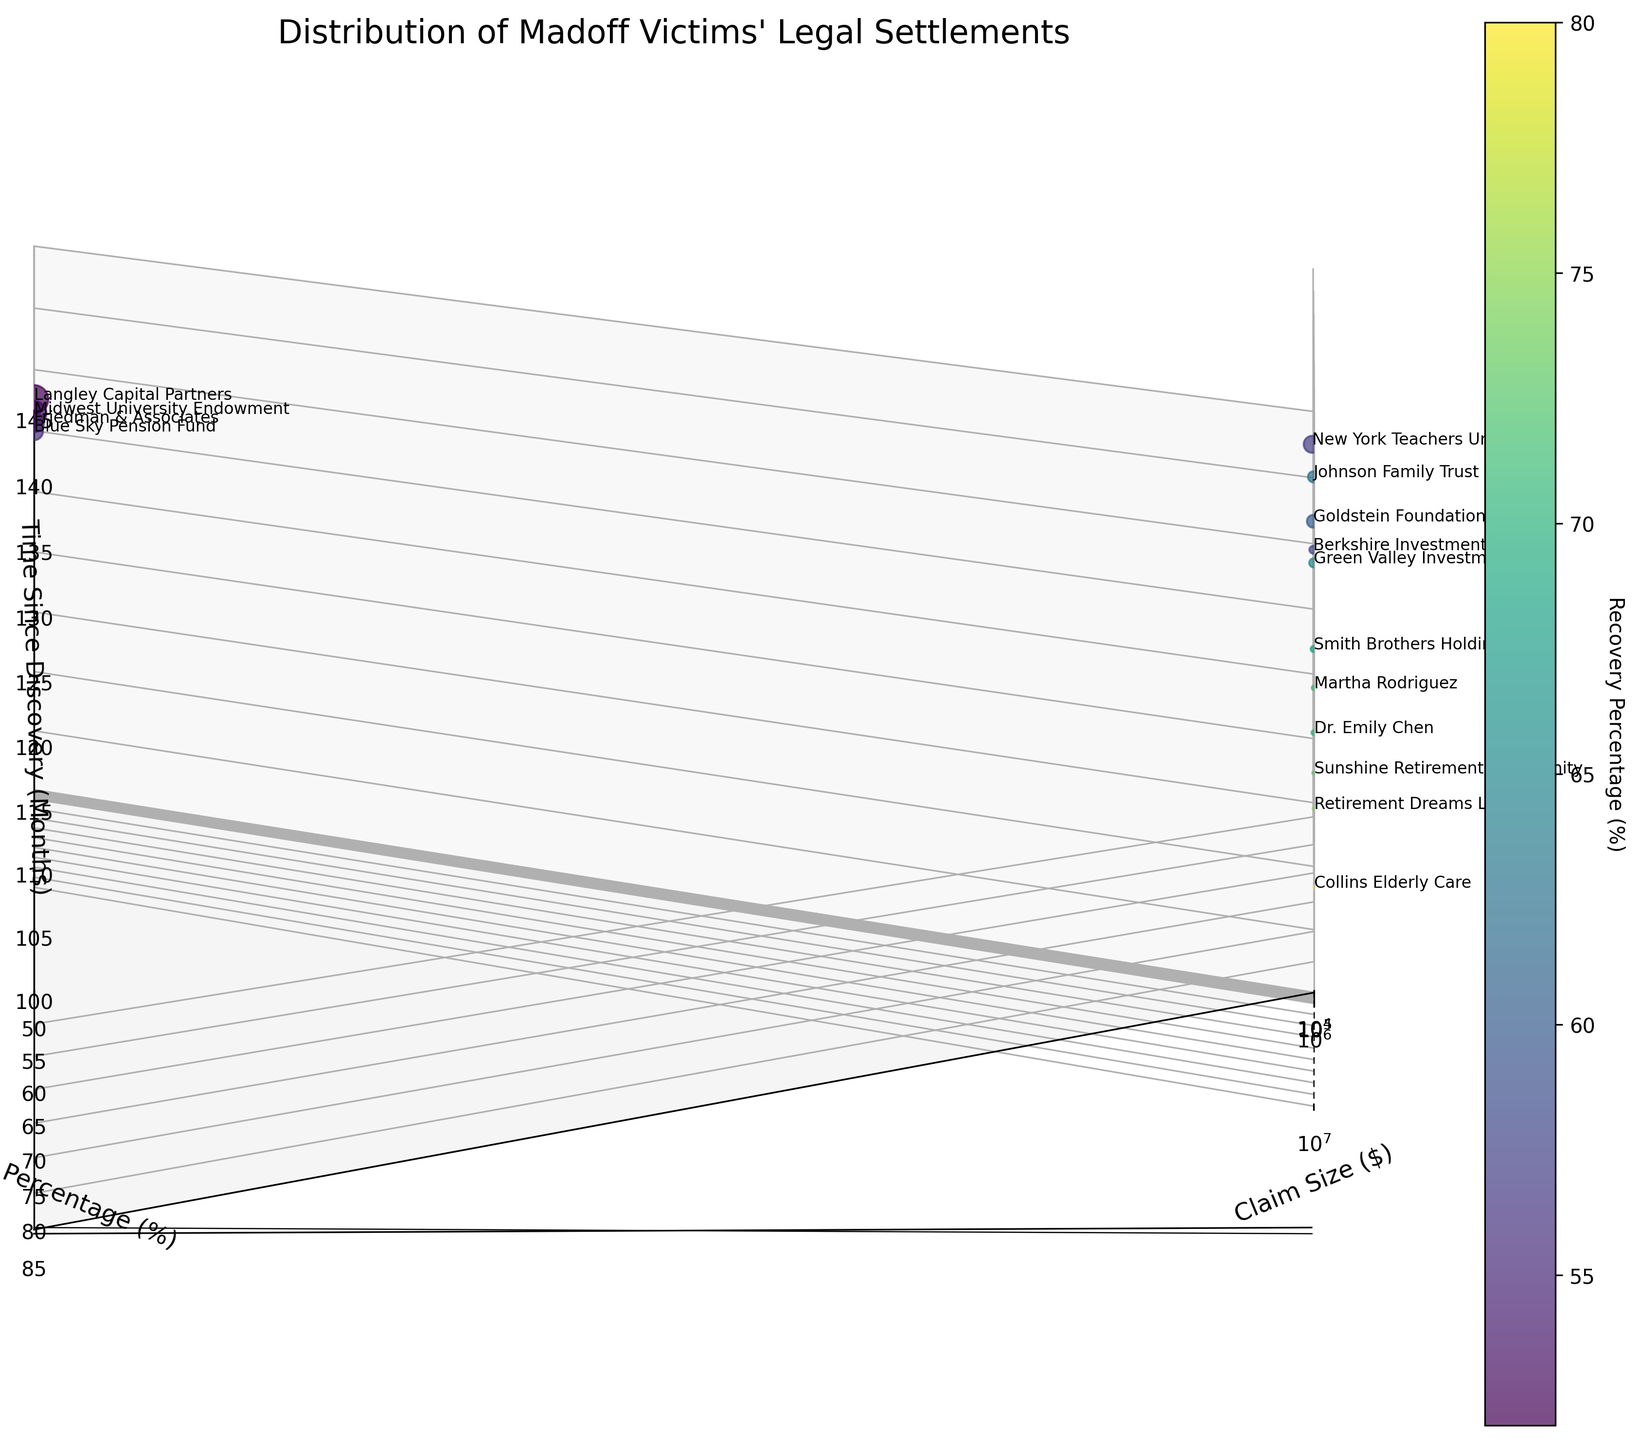What is the title of the figure? The title is clearly shown at the top of the figure. It helps us understand the purpose of the plot.
Answer: Distribution of Madoff Victims' Legal Settlements What is the range of the 'Claim Size' axis? The range can be noted by looking at the x-axis labels from left to right.
Answer: $10,000 to $20,000,000 Which axis represents the 'Time Since Discovery (Months)'? The axis labels are clearly specified. The 'Time Since Discovery (Months)' label is on the z-axis.
Answer: z-axis How many data points are plotted in the figure? We count the number of individual points scattered in the plot. Each point represents a victim.
Answer: 15 Which data point has the highest 'Recovery Percentage'? We look for the point with the highest value on the y-axis (Recovery Percentage)
Answer: Collins Elderly Care What is the relationship between 'Claim Size' and 'Recovery Percentage' for Friedman & Associates? Locate Friedman & Associates on the plot based on labels and check its positions on the 'Claim Size' and 'Recovery Percentage' axes.
Answer: Claim Size: $5,000,000, Recovery Percentage: 55% 1. Identify relevant points.
2. Sum their 'Time Since Discovery (Months)' (132+136+128+134+140+135+126).
3. Compute the average by dividing by the number of points (7). (132+136+128+134+140+135+126)/7 = 135.86
Answer: 135.86 Which data point is located at the highest value on the 'Time Since Discovery (Months)' axis? We look for the point with the maximum value along the z-axis (Time Since Discovery).
Answer: Langley Capital Partners Is there a trend between 'Claim Size' and 'Recovery Percentage'? Observe the general direction of the points. Notice if larger claims have a higher/lower recovery percentage compared to smaller claims.
Answer: No clear trend For Dr. Emily Chen, what is the 'Time Since Discovery (Months)' value? Locate Dr. Emily Chen on the plot based on labels and check its position on the z-axis (Time Since Discovery).
Answer: 114 